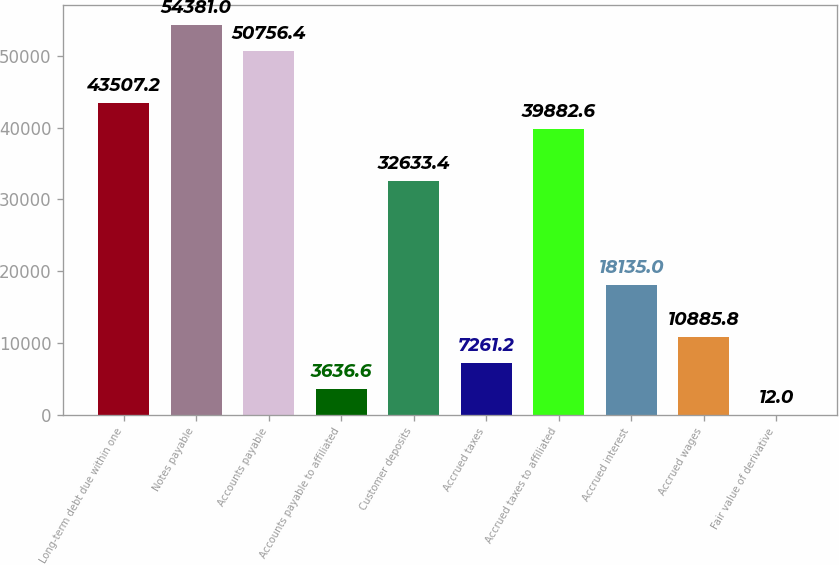<chart> <loc_0><loc_0><loc_500><loc_500><bar_chart><fcel>Long-term debt due within one<fcel>Notes payable<fcel>Accounts payable<fcel>Accounts payable to affiliated<fcel>Customer deposits<fcel>Accrued taxes<fcel>Accrued taxes to affiliated<fcel>Accrued interest<fcel>Accrued wages<fcel>Fair value of derivative<nl><fcel>43507.2<fcel>54381<fcel>50756.4<fcel>3636.6<fcel>32633.4<fcel>7261.2<fcel>39882.6<fcel>18135<fcel>10885.8<fcel>12<nl></chart> 